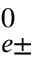Convert formula to latex. <formula><loc_0><loc_0><loc_500><loc_500>^ { 0 } _ { e \pm }</formula> 